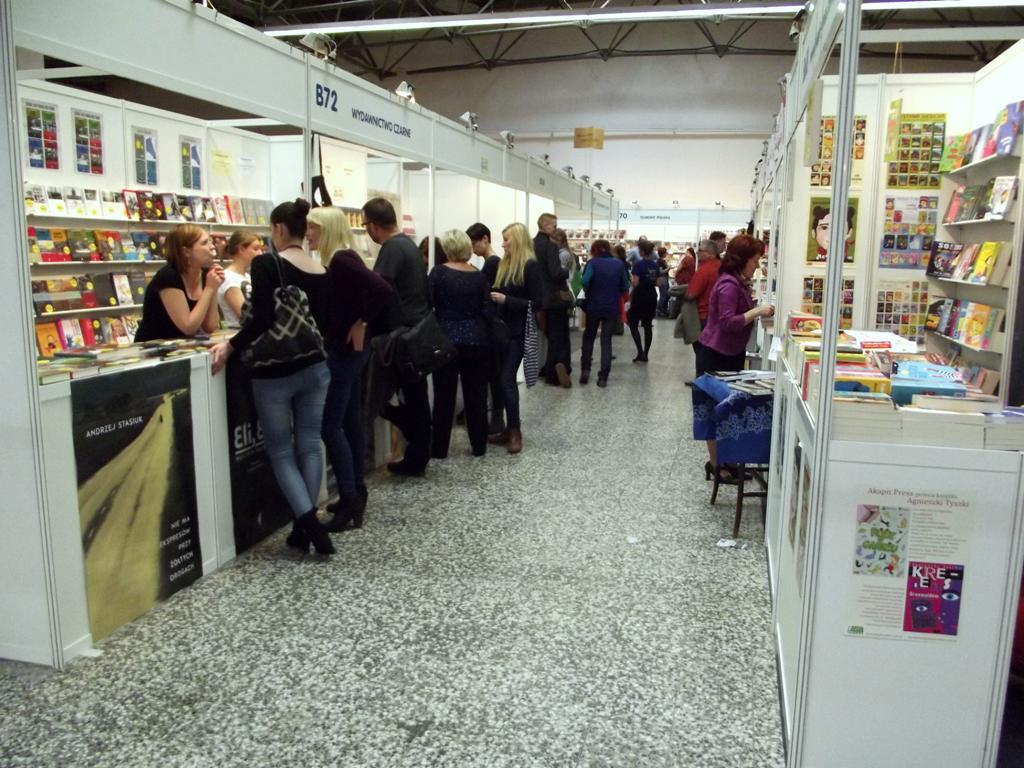In one or two sentences, can you explain what this image depicts? In this picture I can see some stoles inside of the building, around we can see few people. 